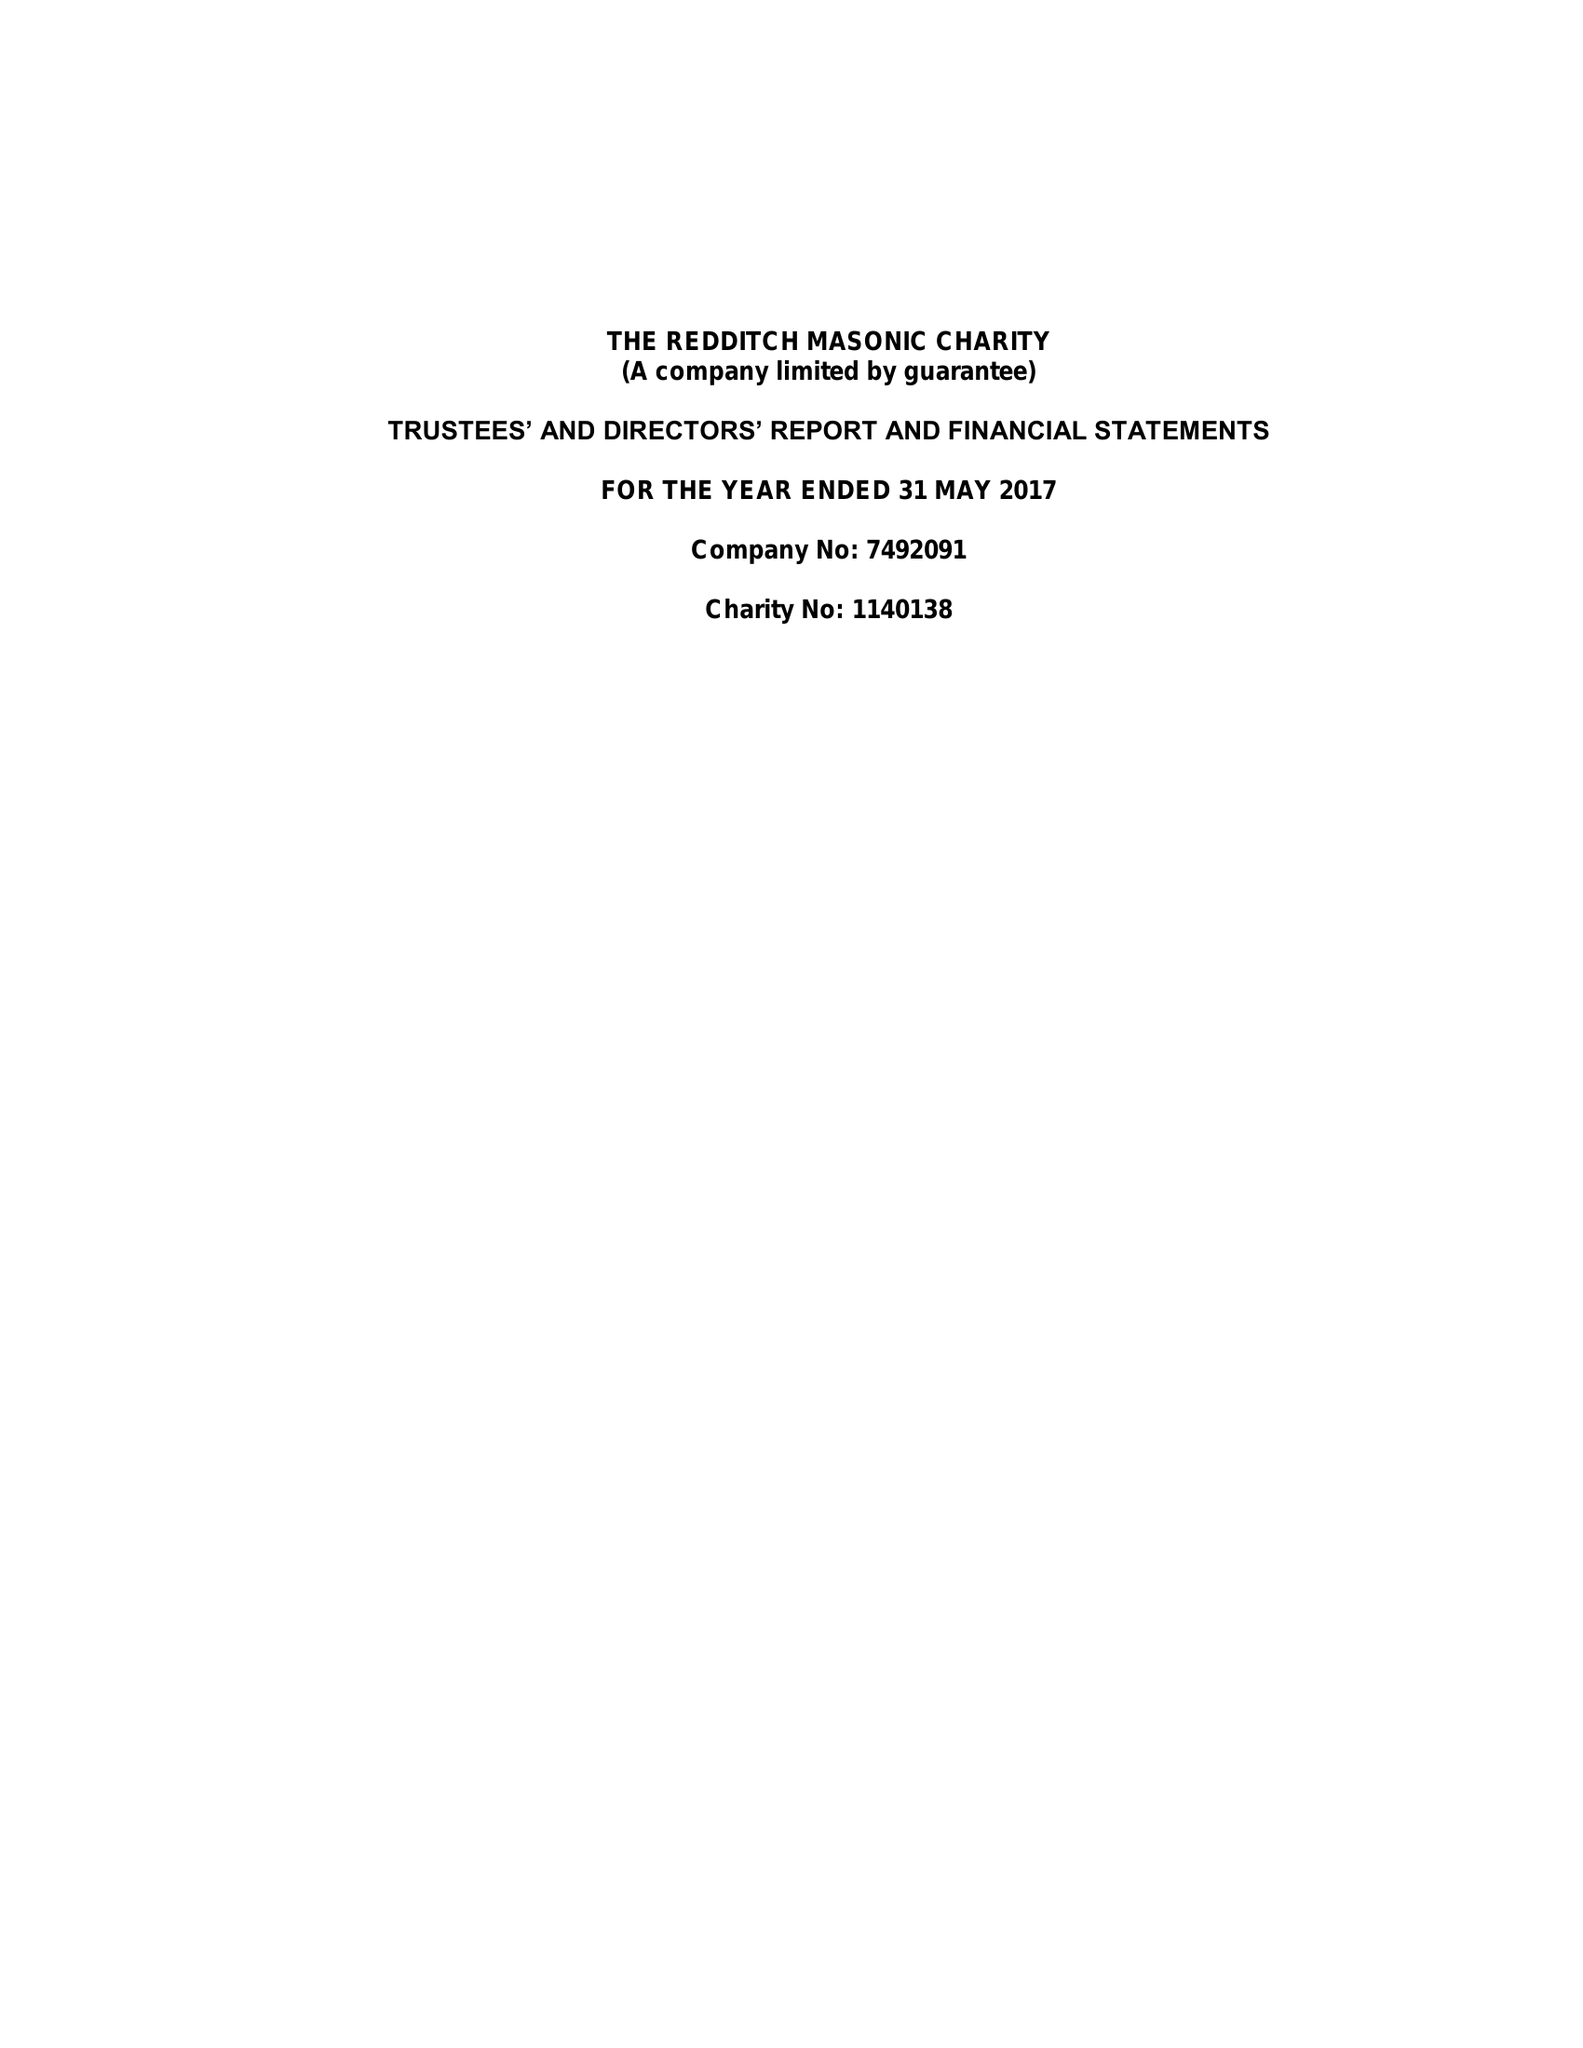What is the value for the address__street_line?
Answer the question using a single word or phrase. 4 DUNSTALL CLOSE 